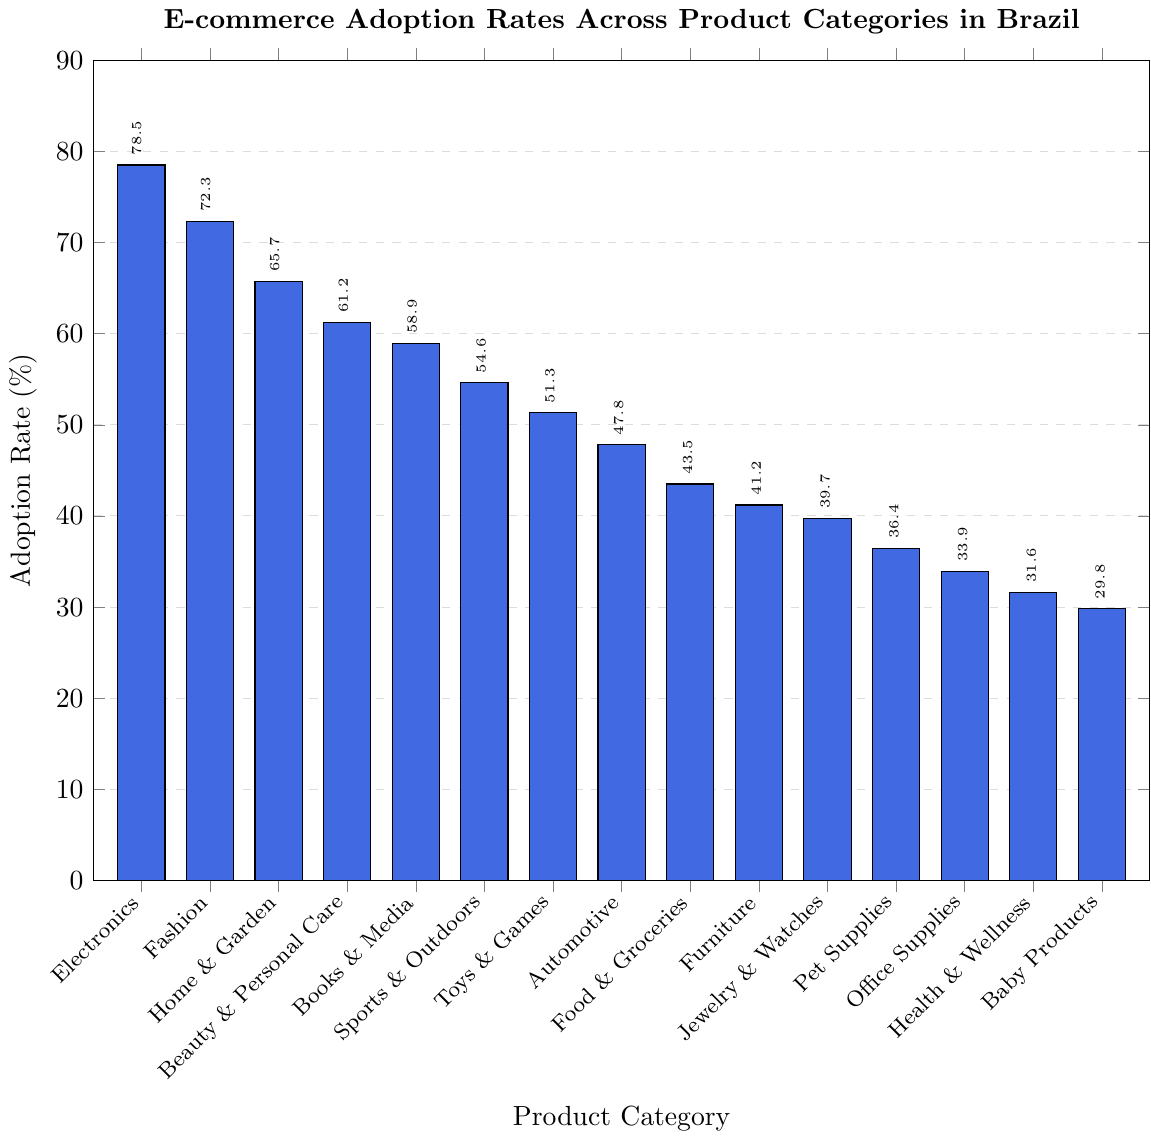Which product category has the highest E-commerce adoption rate? The bar with the greatest height represents the highest adoption rate. Here, it is the bar labeled "Electronics" at 78.5%.
Answer: Electronics What is the E-commerce adoption rate for Beauty & Personal Care compared to Home & Garden? Find and compare the heights of the bars for Beauty & Personal Care and Home & Garden. Beauty & Personal Care is 61.2% and Home & Garden is 65.7%, so Beauty & Personal Care is less than Home & Garden.
Answer: Beauty & Personal Care is less Which product category has an adoption rate closest to 50%? Identify the bars with values around 50%. The closest is the "Toys & Games" category with a rate of 51.3%.
Answer: Toys & Games What is the difference in adoption rates between Food & Groceries and Furniture? Subtract the adoption rate of Furniture (41.2%) from Food & Groceries (43.5%). So, 43.5% - 41.2% = 2.3%.
Answer: 2.3% Which three product categories have the lowest E-commerce adoption rates? Identify the three shortest bars in the chart. These bars correspond to "Baby Products" (29.8%), "Health & Wellness" (31.6%), and "Office Supplies" (33.9%).
Answer: Baby Products, Health & Wellness, Office Supplies What is the average adoption rate for the categories with an adoption rate higher than 60%? Identify categories with rates higher than 60%: Electronics (78.5%), Fashion (72.3%), Home & Garden (65.7%), and Beauty & Personal Care (61.2%). Calculate the average: (78.5 + 72.3 + 65.7 + 61.2) / 4 = 69.425%.
Answer: 69.425% How many product categories have adoption rates greater than 50%? Count the number of bars with heights greater than 50%. These are: Electronics, Fashion, Home & Garden, Beauty & Personal Care, Books & Media, Sports & Outdoors, and Toys & Games.
Answer: 7 What is the median adoption rate across all product categories? Order the adoption rates and find the middle value. Sorted rates are: 29.8, 31.6, 33.9, 36.4, 39.7, 41.2, 43.5, 47.8, 51.3, 54.6, 58.9, 61.2, 65.7, 72.3, 78.5. The median is the 8th value, which is 47.8%.
Answer: 47.8% 